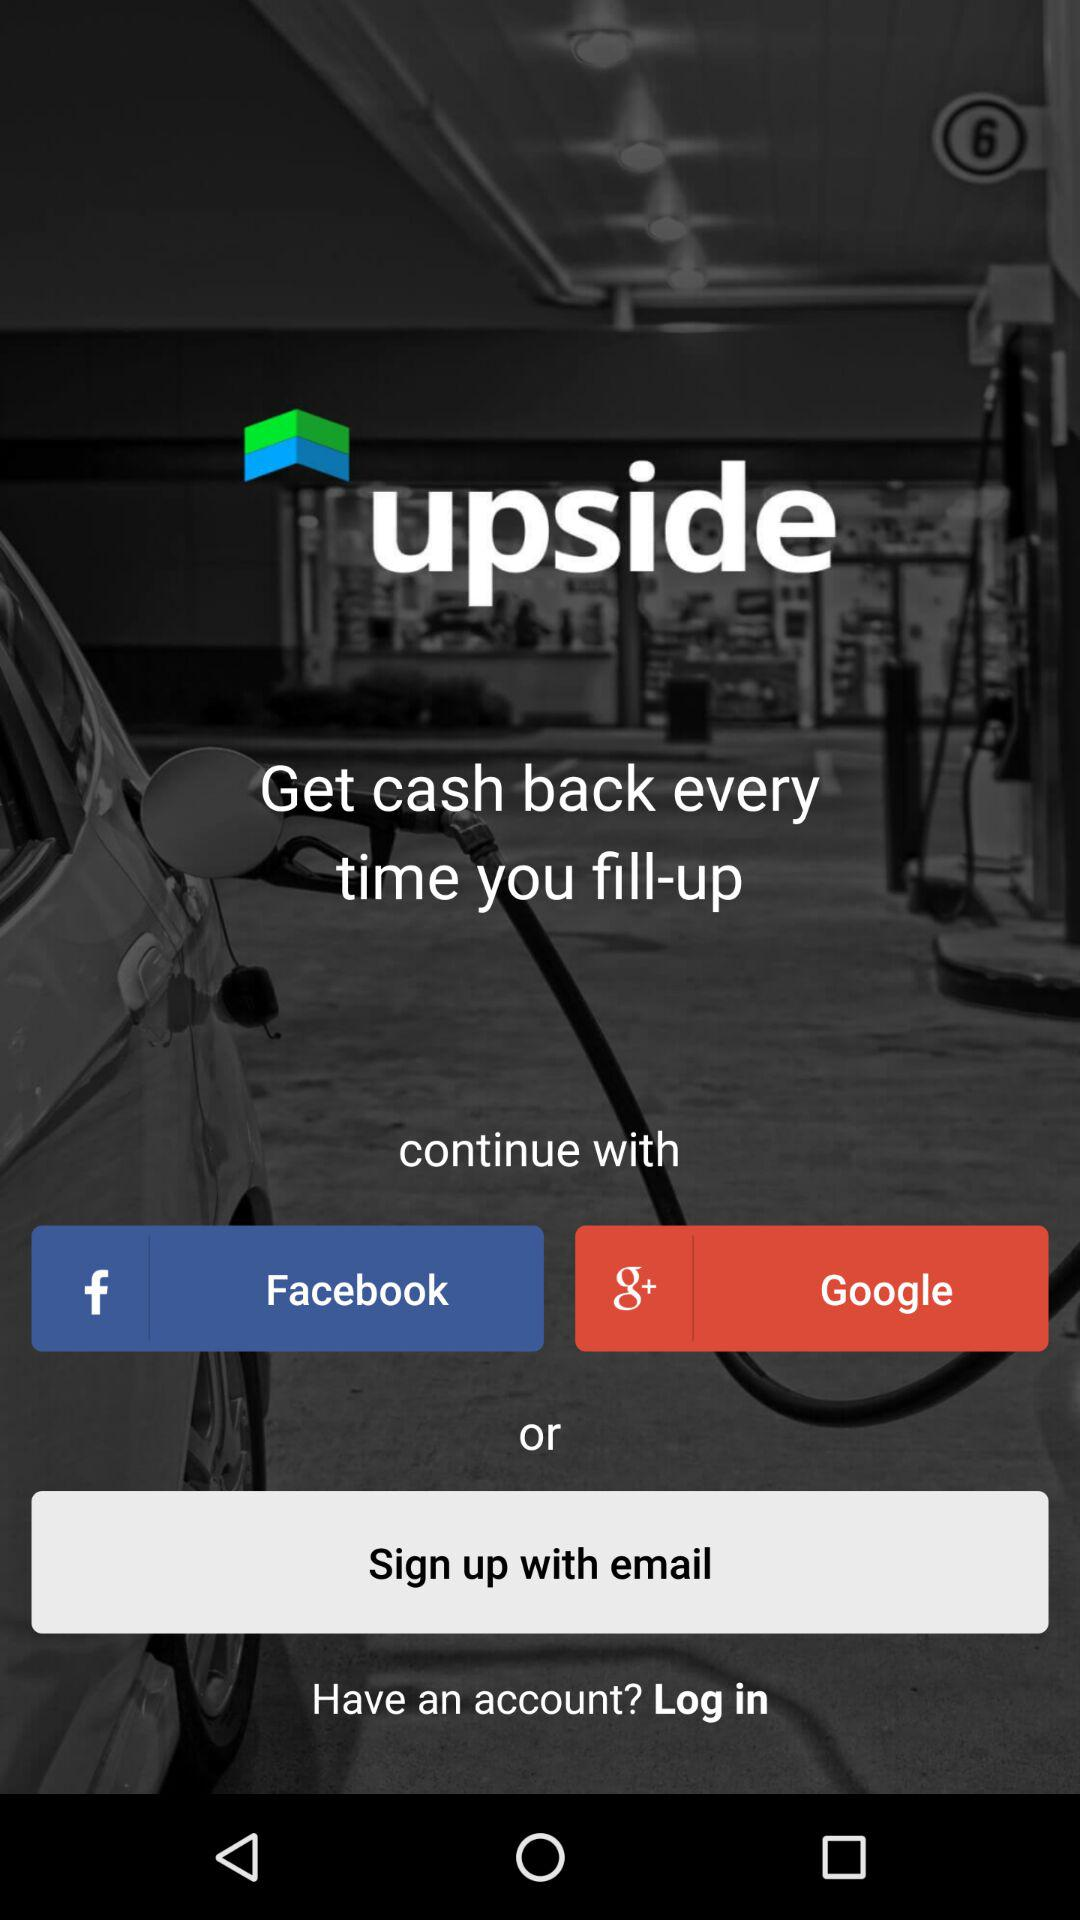What accounts can I use to sign up? You can use "email" to sign up. 